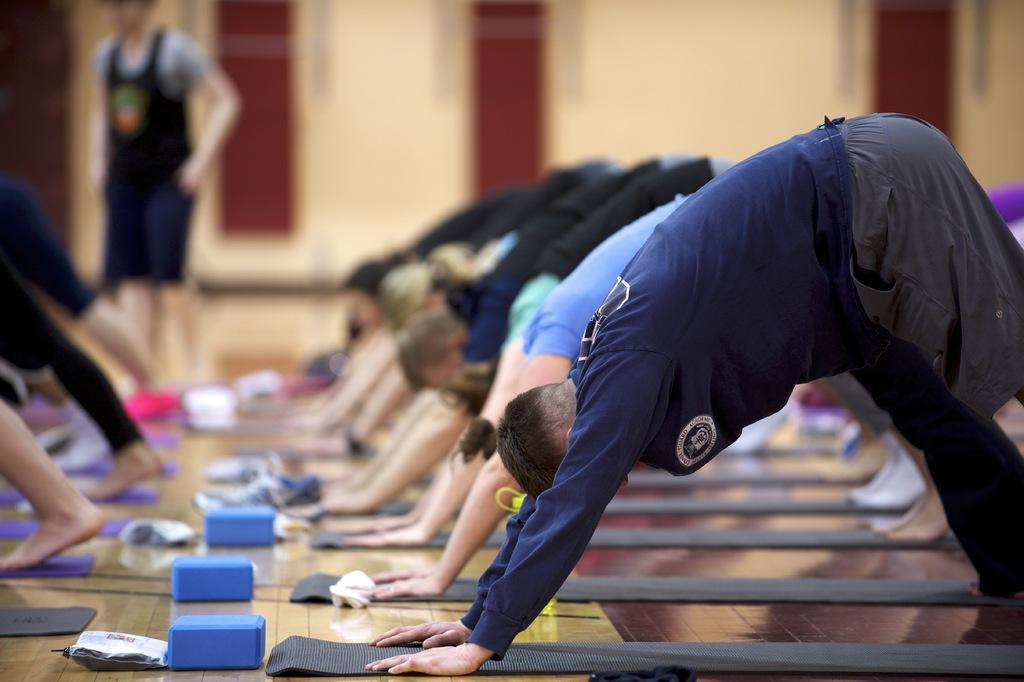What are the people in the image doing? The people in the image are performing exercises. What surface are the exercises being done on? The exercises are being done on a mat. Are there any objects in front of the mat? Yes, there are objects in front of the mat. What type of power is being generated by the people performing exercises in the image? There is no indication in the image that the people performing exercises are generating any power. 